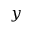<formula> <loc_0><loc_0><loc_500><loc_500>y</formula> 